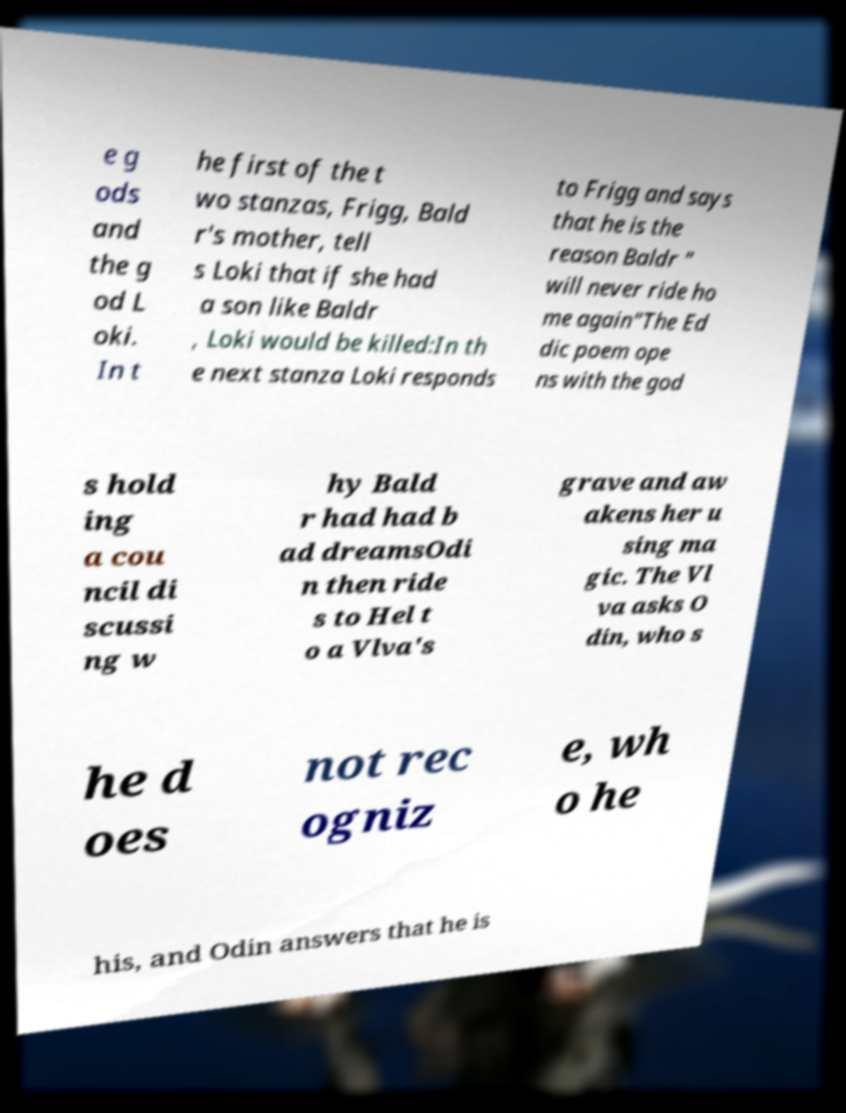What messages or text are displayed in this image? I need them in a readable, typed format. e g ods and the g od L oki. In t he first of the t wo stanzas, Frigg, Bald r's mother, tell s Loki that if she had a son like Baldr , Loki would be killed:In th e next stanza Loki responds to Frigg and says that he is the reason Baldr " will never ride ho me again"The Ed dic poem ope ns with the god s hold ing a cou ncil di scussi ng w hy Bald r had had b ad dreamsOdi n then ride s to Hel t o a Vlva's grave and aw akens her u sing ma gic. The Vl va asks O din, who s he d oes not rec ogniz e, wh o he his, and Odin answers that he is 